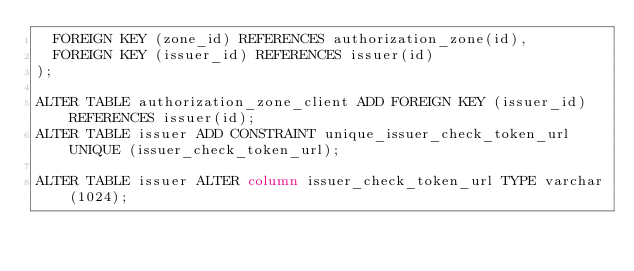<code> <loc_0><loc_0><loc_500><loc_500><_SQL_>  FOREIGN KEY (zone_id) REFERENCES authorization_zone(id),
  FOREIGN KEY (issuer_id) REFERENCES issuer(id)
);

ALTER TABLE authorization_zone_client ADD FOREIGN KEY (issuer_id) REFERENCES issuer(id);
ALTER TABLE issuer ADD CONSTRAINT unique_issuer_check_token_url UNIQUE (issuer_check_token_url);

ALTER TABLE issuer ALTER column issuer_check_token_url TYPE varchar(1024);</code> 